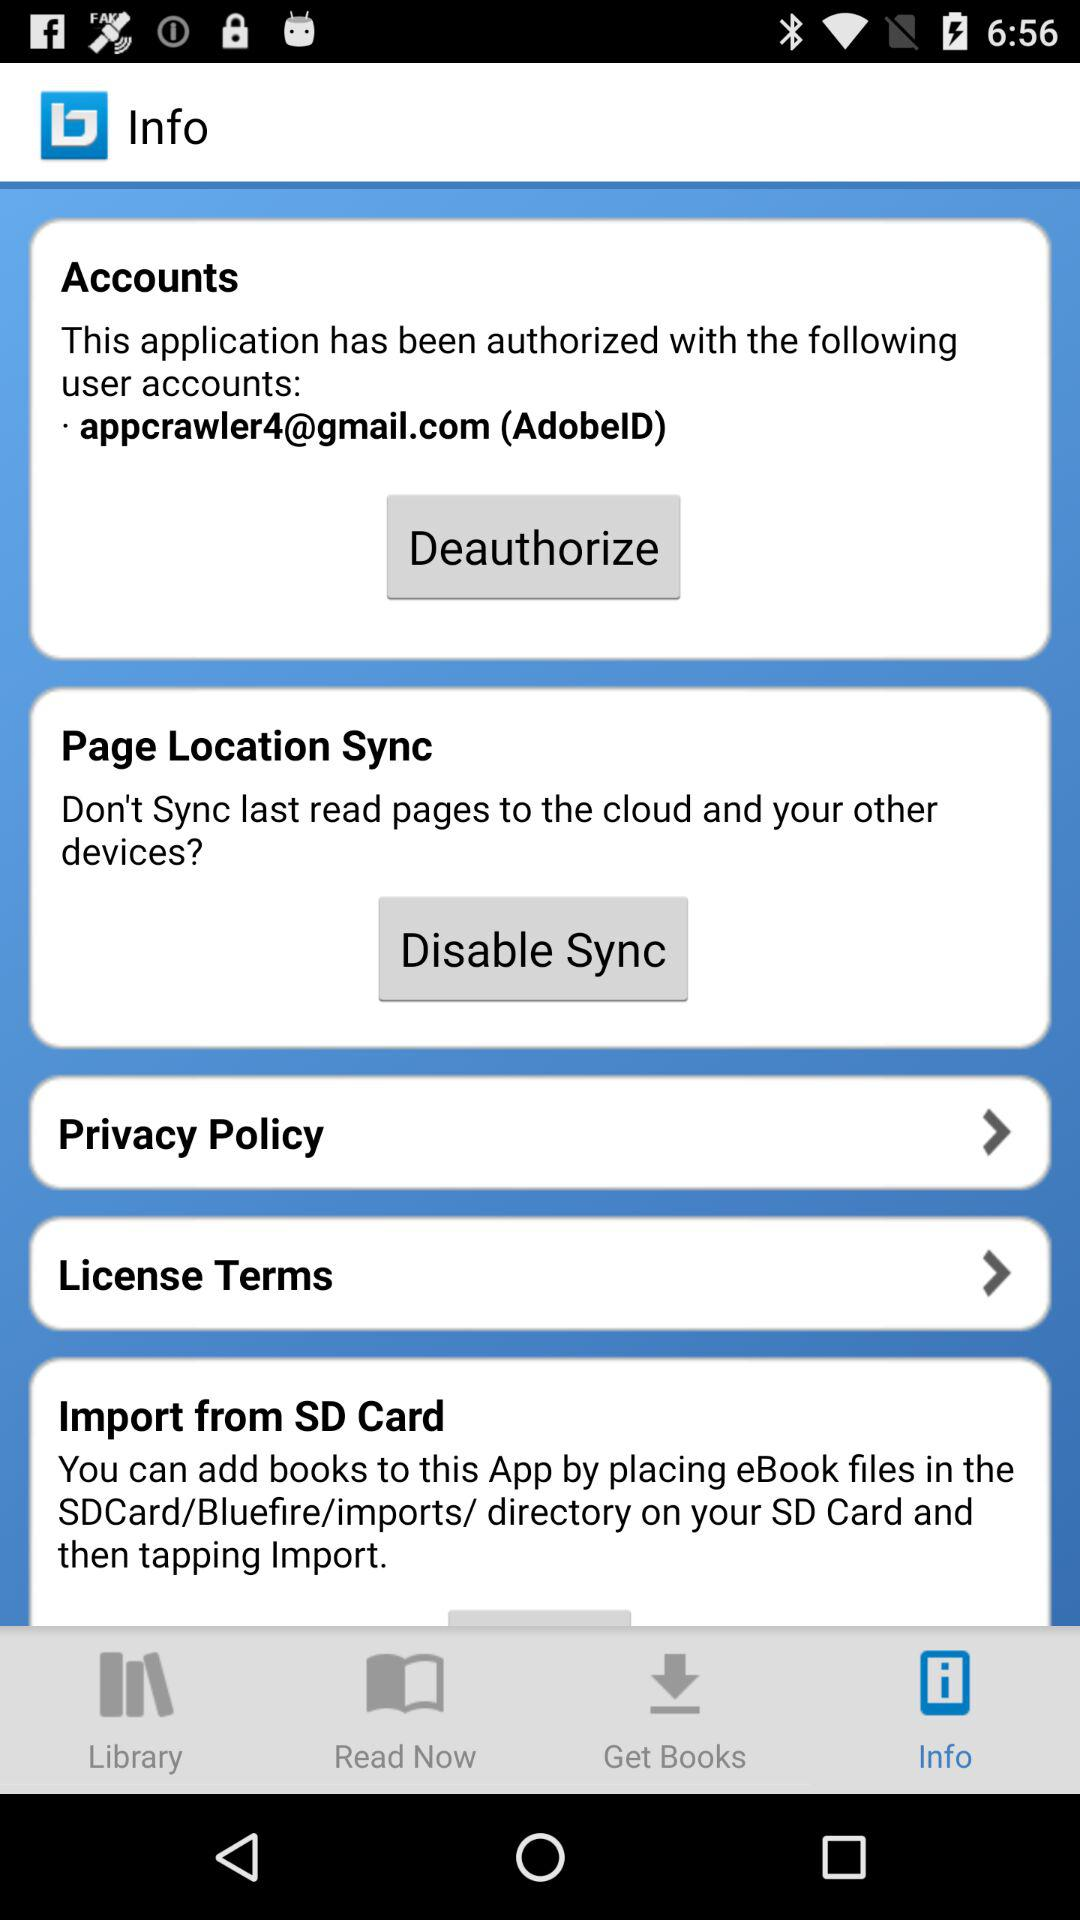What option is shown for "Page Location Sync"? The option is "Disable Sync". 